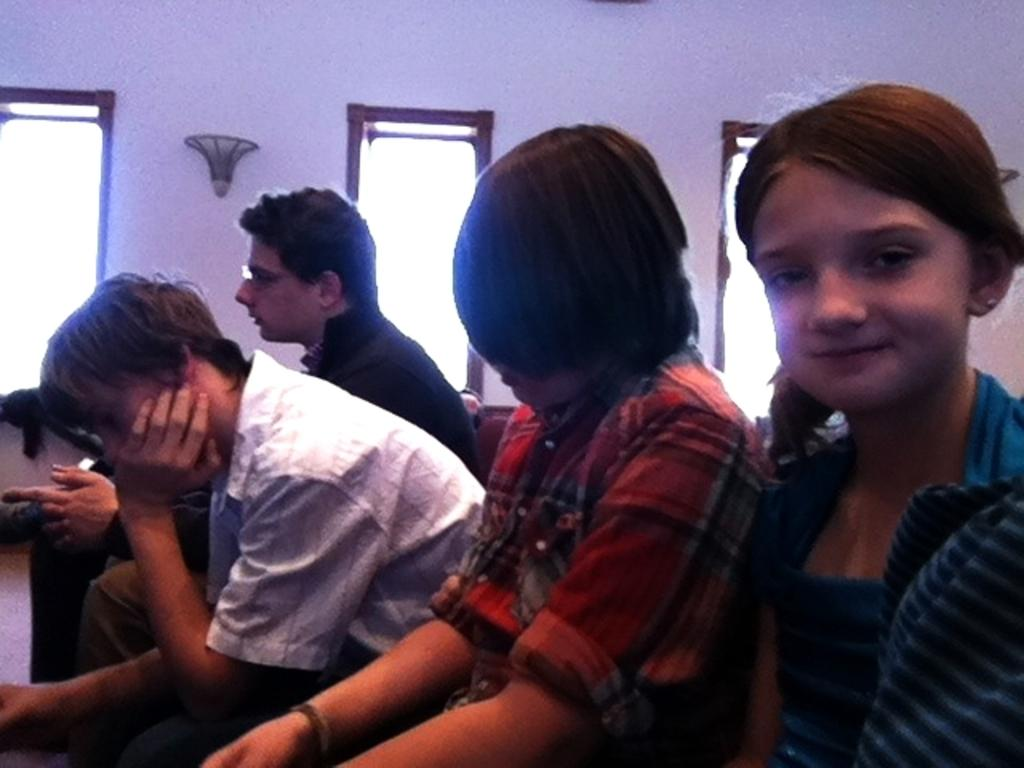How many people are sitting in the image? There are four persons sitting in the image. Can you describe the expression of one of the persons? A girl is smiling in the image. What can be seen in the background of the image? There is a wall, showpieces, and other objects visible in the background of the image. How many books are stacked on the coil in the image? There are no books or coils present in the image. What is the occasion for the birth celebration in the image? There is no mention of a birth or celebration in the image. 